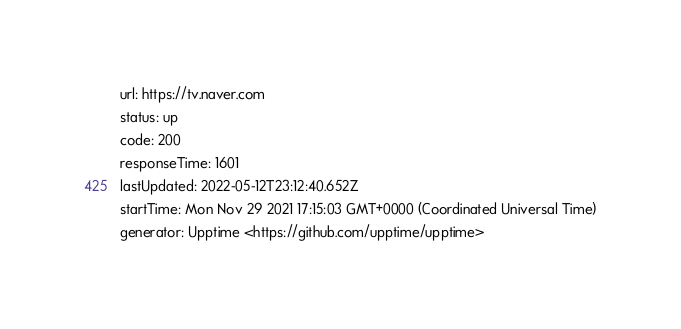Convert code to text. <code><loc_0><loc_0><loc_500><loc_500><_YAML_>url: https://tv.naver.com
status: up
code: 200
responseTime: 1601
lastUpdated: 2022-05-12T23:12:40.652Z
startTime: Mon Nov 29 2021 17:15:03 GMT+0000 (Coordinated Universal Time)
generator: Upptime <https://github.com/upptime/upptime>
</code> 